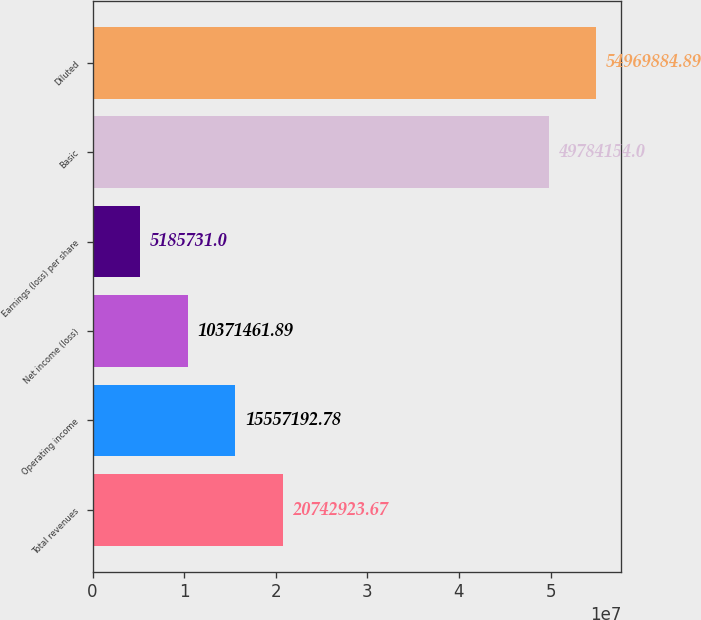Convert chart. <chart><loc_0><loc_0><loc_500><loc_500><bar_chart><fcel>Total revenues<fcel>Operating income<fcel>Net income (loss)<fcel>Earnings (loss) per share<fcel>Basic<fcel>Diluted<nl><fcel>2.07429e+07<fcel>1.55572e+07<fcel>1.03715e+07<fcel>5.18573e+06<fcel>4.97842e+07<fcel>5.49699e+07<nl></chart> 